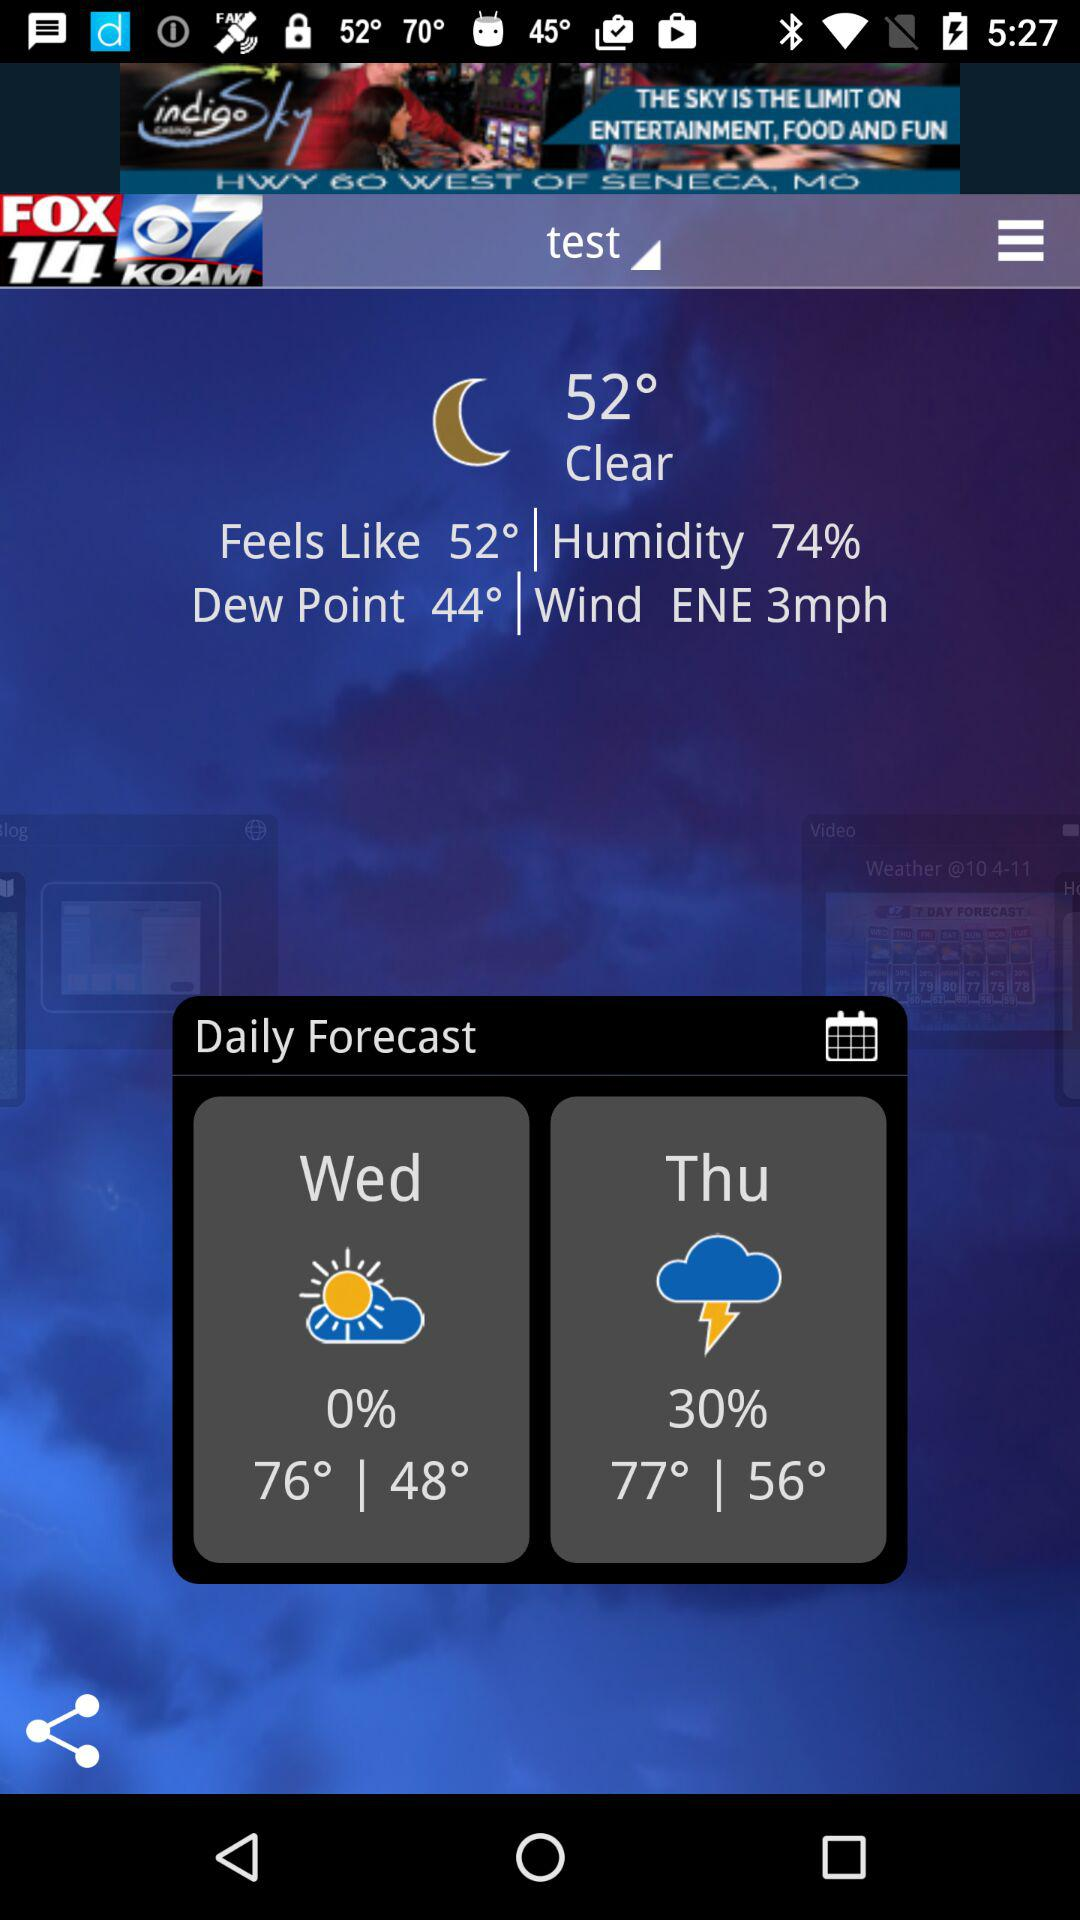How many days are in the forecast?
Answer the question using a single word or phrase. 2 